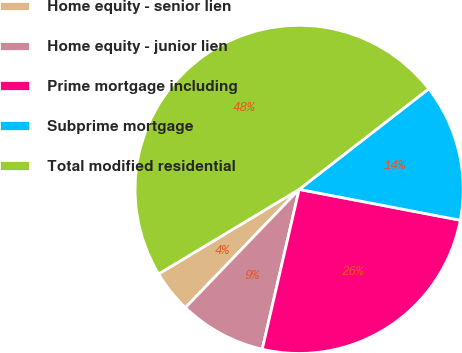<chart> <loc_0><loc_0><loc_500><loc_500><pie_chart><fcel>Home equity - senior lien<fcel>Home equity - junior lien<fcel>Prime mortgage including<fcel>Subprime mortgage<fcel>Total modified residential<nl><fcel>4.19%<fcel>8.58%<fcel>25.6%<fcel>13.51%<fcel>48.12%<nl></chart> 